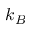<formula> <loc_0><loc_0><loc_500><loc_500>k _ { B }</formula> 